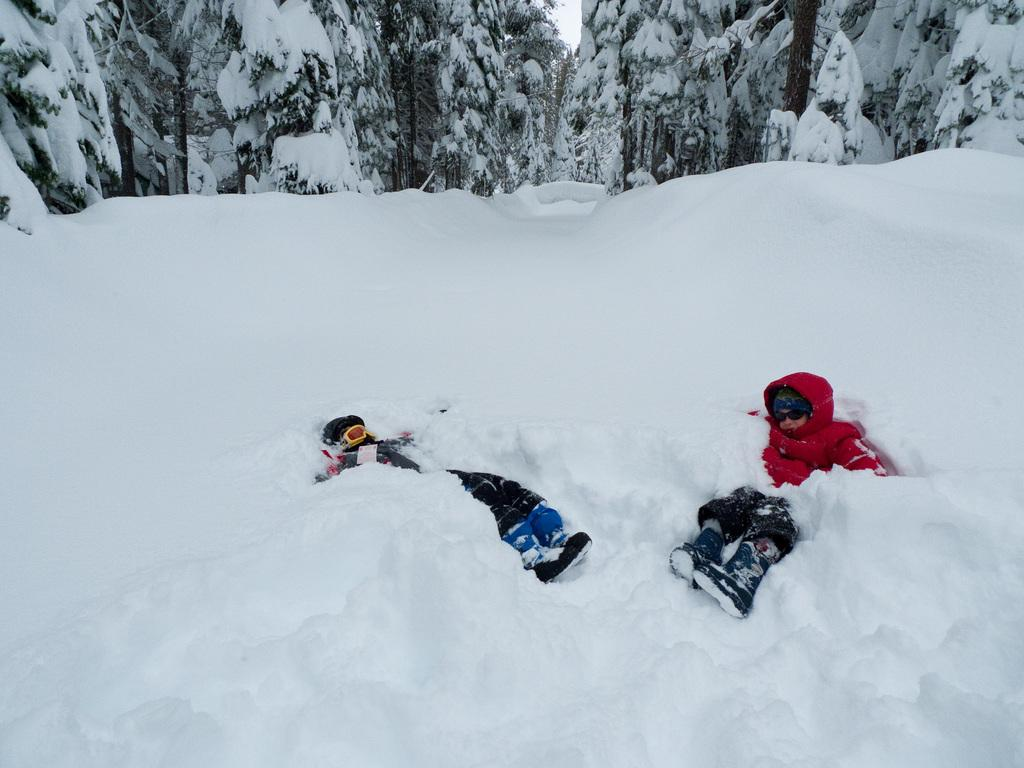How many people are in the image? There are two persons in the image. What are the persons doing in the image? The persons are sleeping in the image. Where are the persons located in the image? The persons are in the snow in the image. What can be seen in the background of the image? There are trees in the background of the image. How are the trees in the background of the image? The trees in the background of the image are covered with snow. What type of goat can be seen playing with the persons in the image? There is no goat present in the image; the persons are sleeping in the snow. What role do the parents play in the image? There is no mention of parents or their role in the image, as it only features two persons sleeping in the snow. 